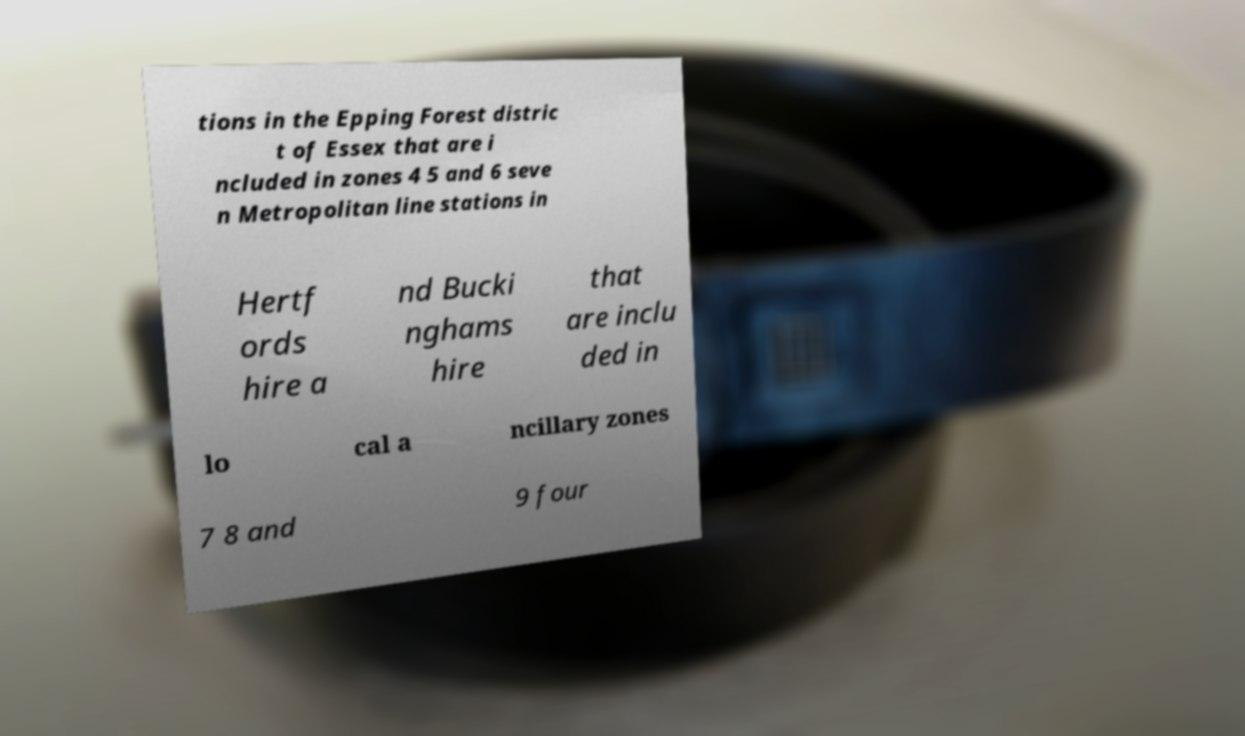What messages or text are displayed in this image? I need them in a readable, typed format. tions in the Epping Forest distric t of Essex that are i ncluded in zones 4 5 and 6 seve n Metropolitan line stations in Hertf ords hire a nd Bucki nghams hire that are inclu ded in lo cal a ncillary zones 7 8 and 9 four 